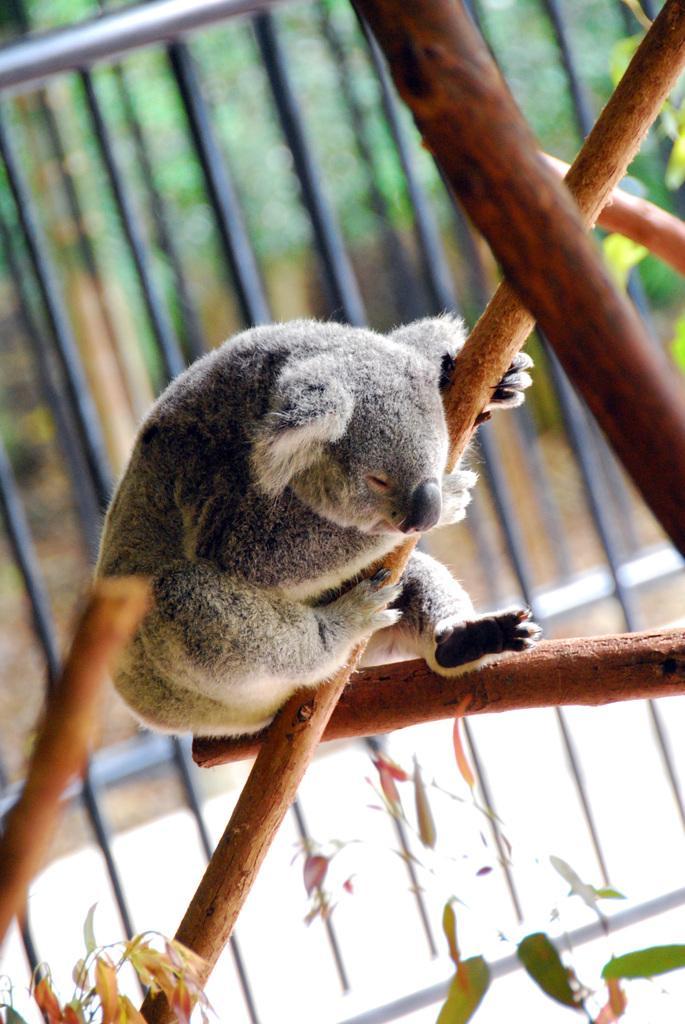Could you give a brief overview of what you see in this image? In this image I can see an animal which is in gray and white color holding a stick. Background I can see a railing. 